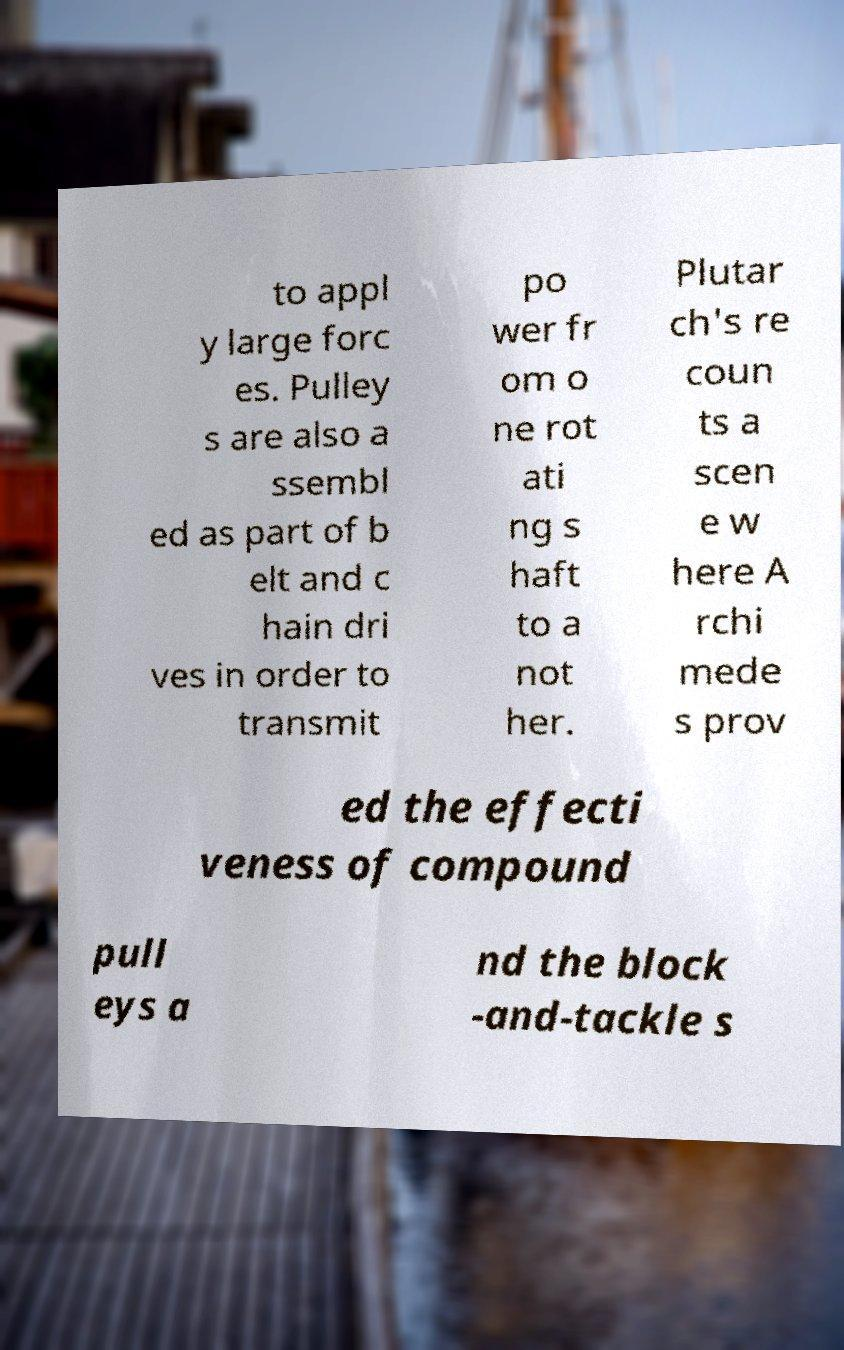Please read and relay the text visible in this image. What does it say? to appl y large forc es. Pulley s are also a ssembl ed as part of b elt and c hain dri ves in order to transmit po wer fr om o ne rot ati ng s haft to a not her. Plutar ch's re coun ts a scen e w here A rchi mede s prov ed the effecti veness of compound pull eys a nd the block -and-tackle s 